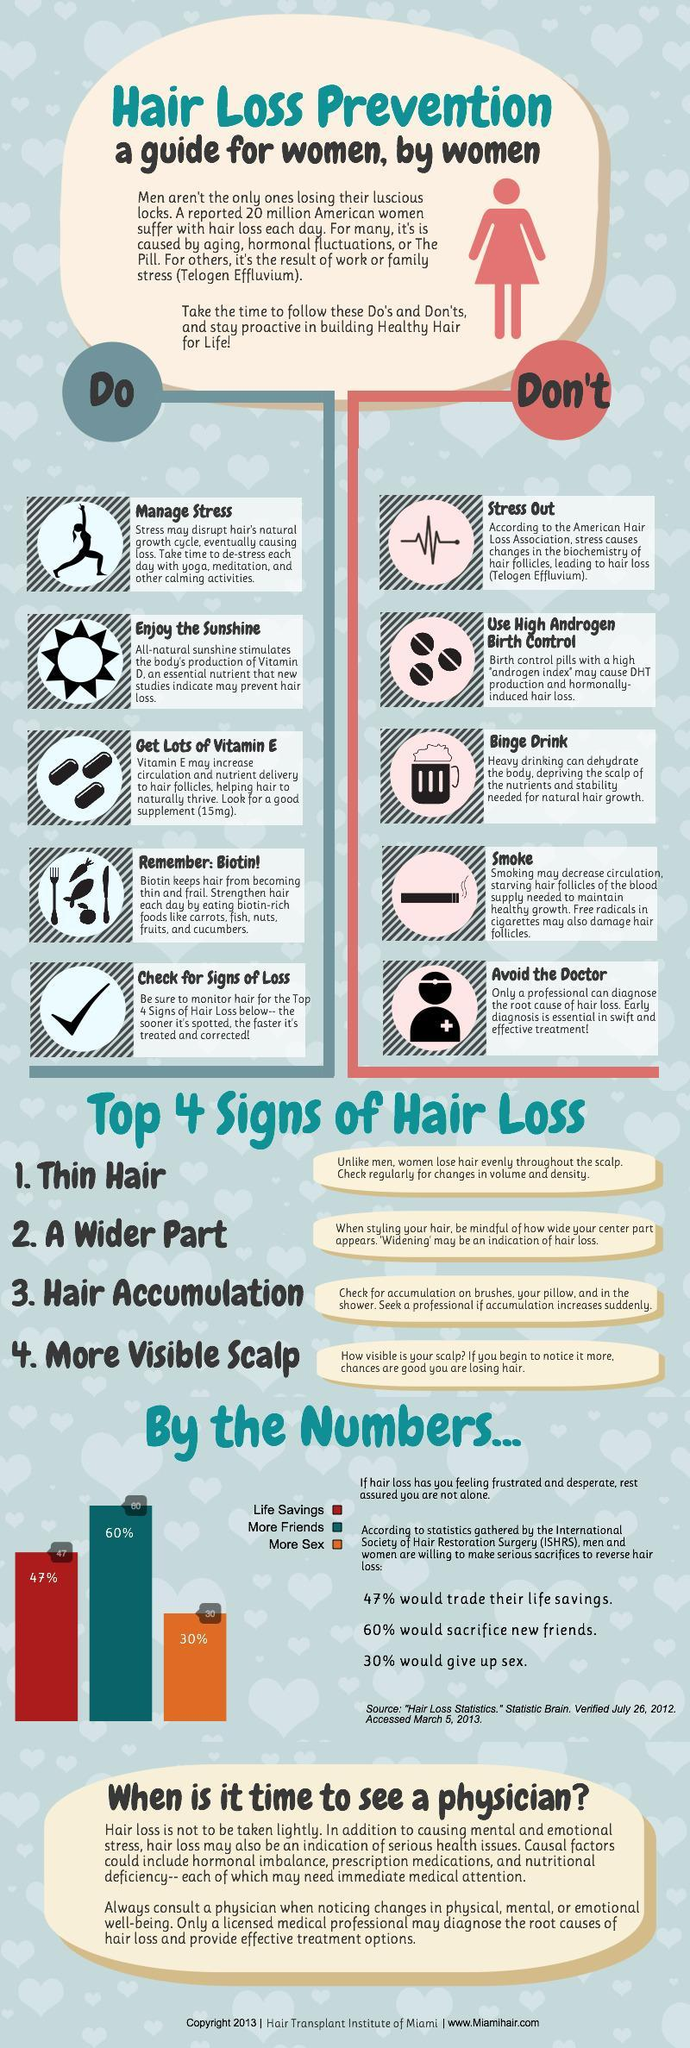Which vitamin are essential for good hair growth?
Answer the question with a short phrase. Vitamin D, Vitamin E 